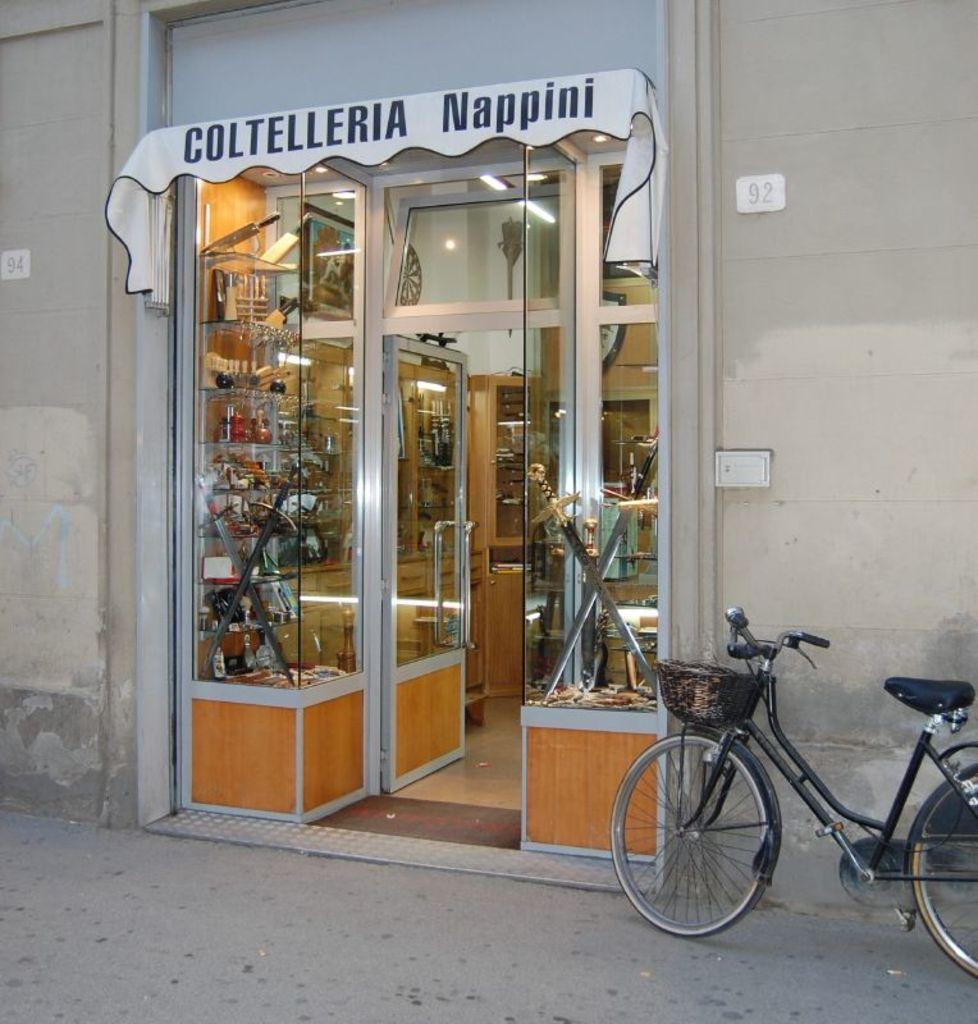What type of establishment is shown in the image? The image depicts a store. What mode of transportation can be seen parked outside the store? There is a bicycle parked in the image. What type of items are visible in the store? Swords are visible in the image. What is the purpose of the name cloth in the image? The name cloth is likely used to display the name or logo of the store. What type of information is displayed on the wall in the image? There are numbers on the wall in the image. What type of anger is displayed by the swords in the image? The swords in the image do not display any type of anger; they are inanimate objects. 